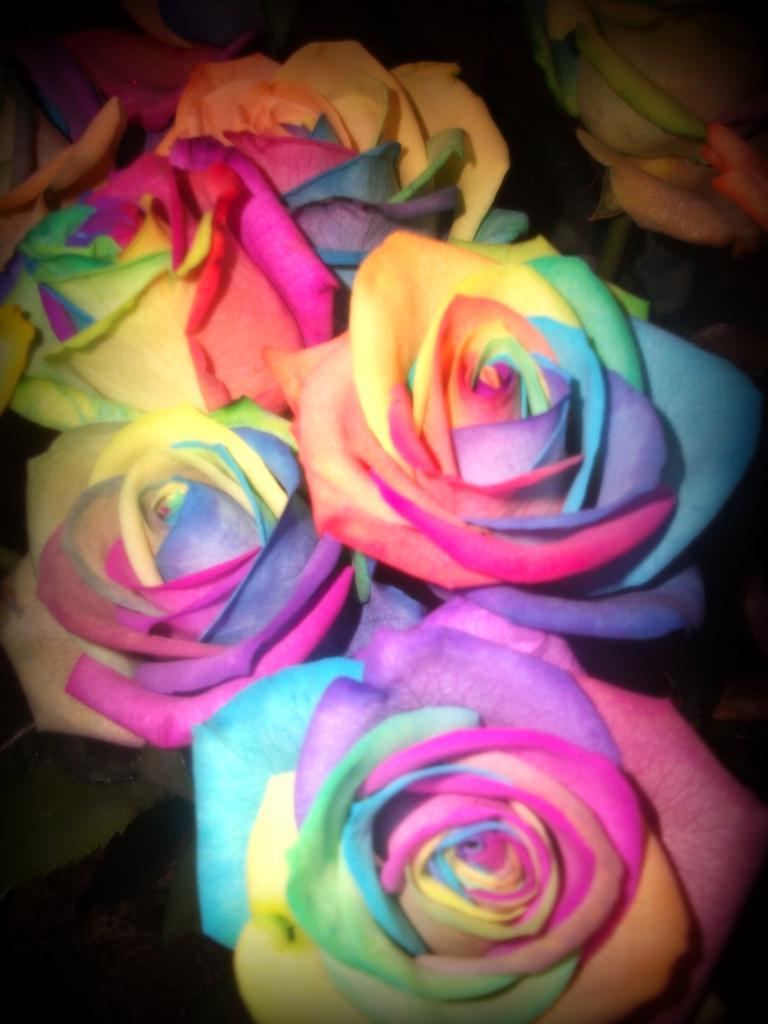What type of flowers are in the image? There are colorful roses in the image. What type of hair can be seen on the roses in the image? Roses do not have hair, so there is no hair present on the roses in the image. 